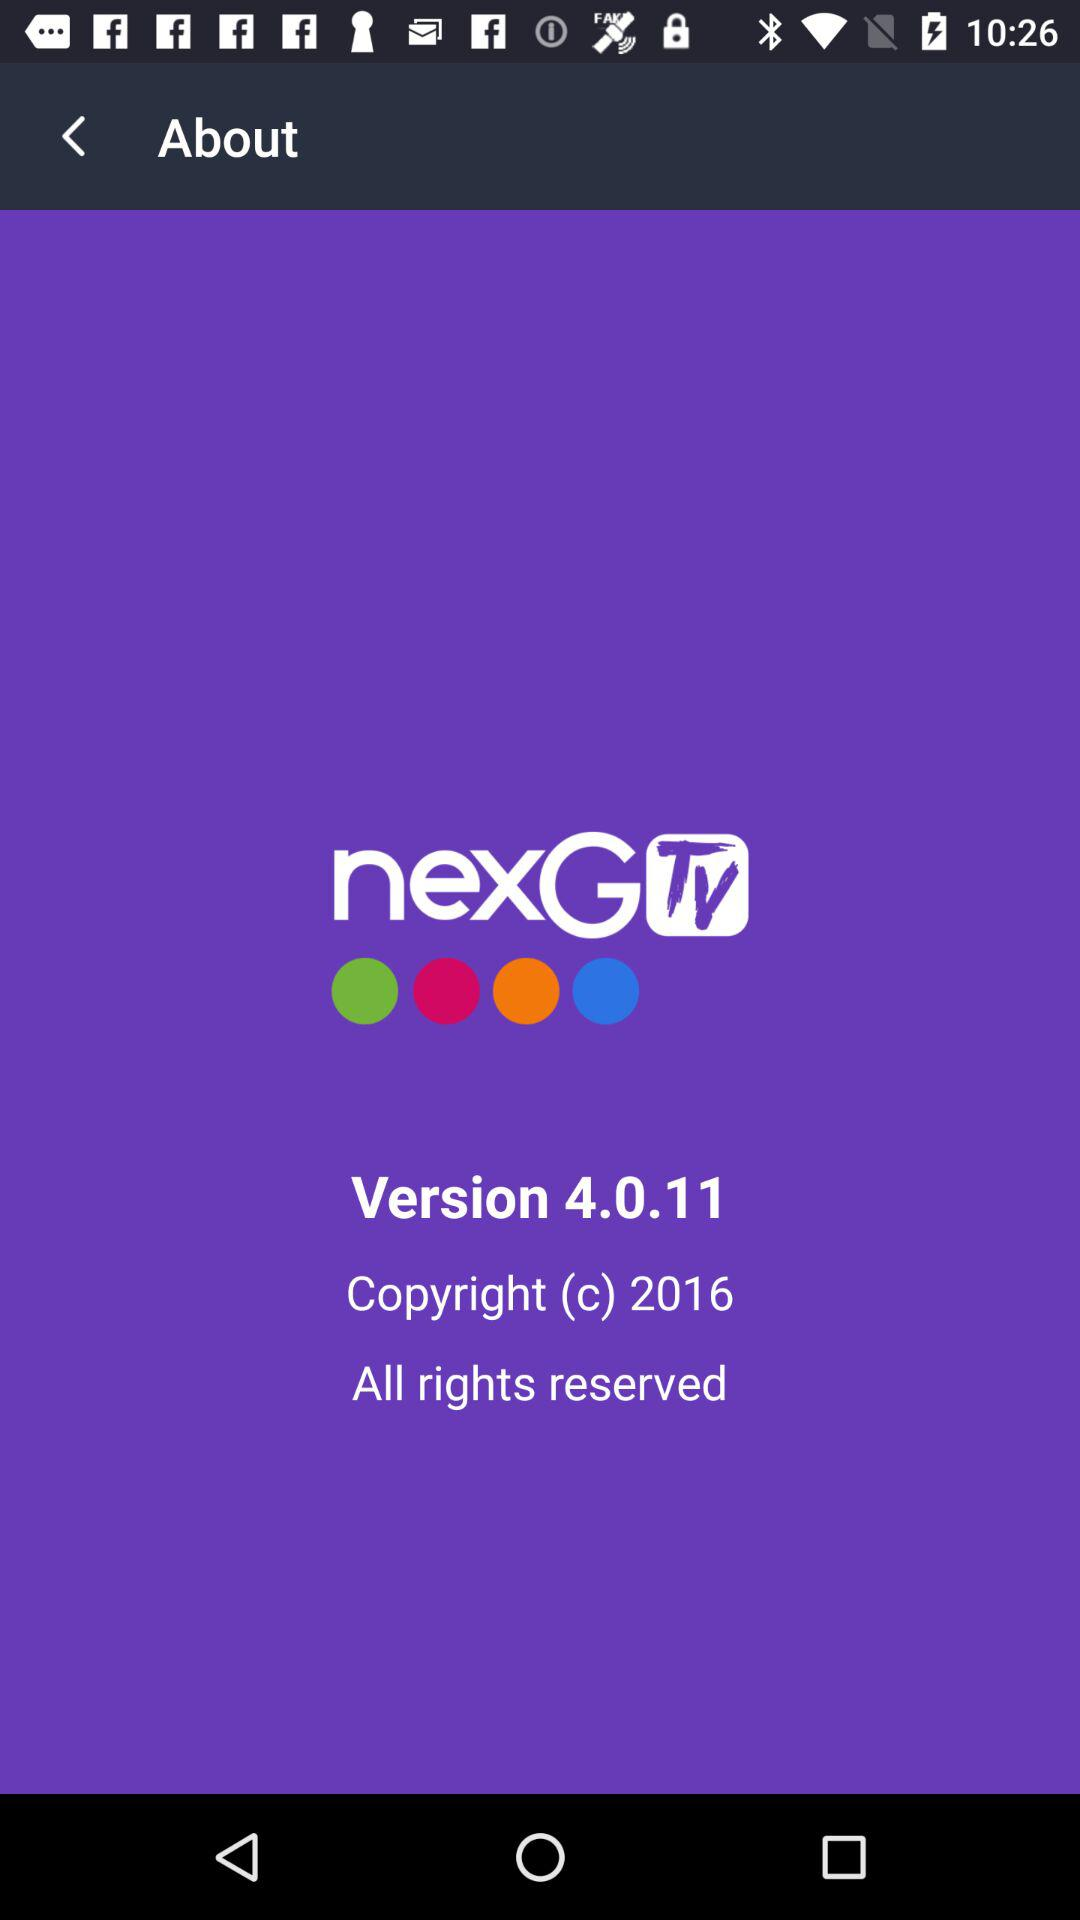What is the version? The version is 4.0.11. 